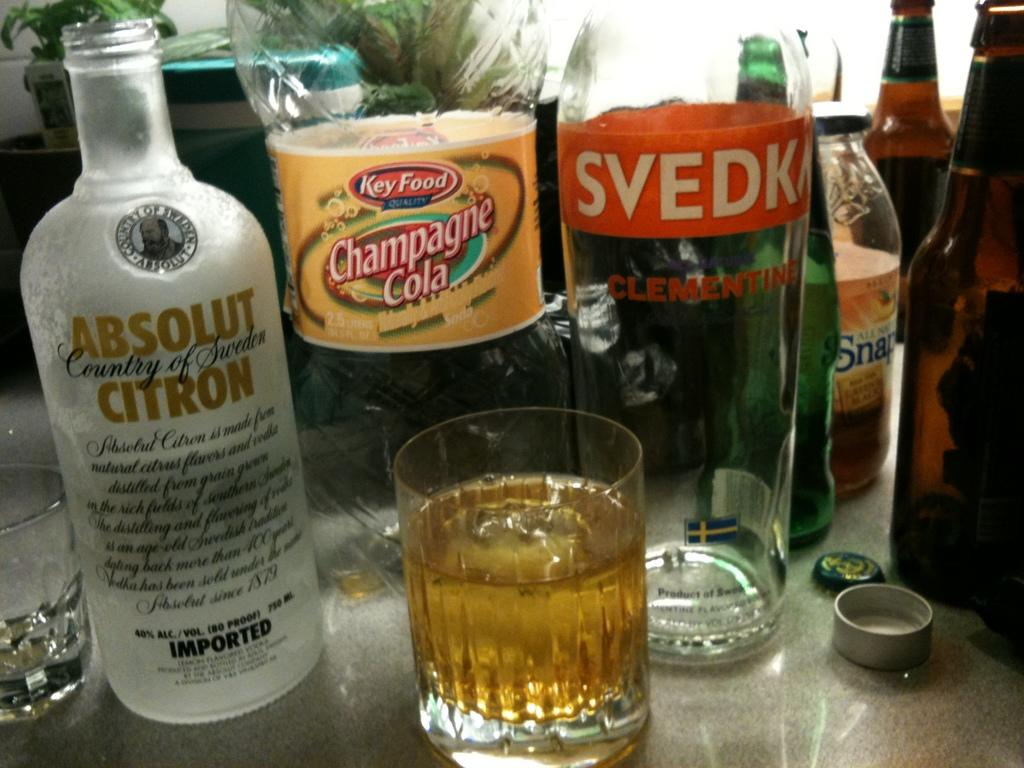Provide a one-sentence caption for the provided image. Multiple bottles of alcohol and a cola bottle are lined up in front of glass. 